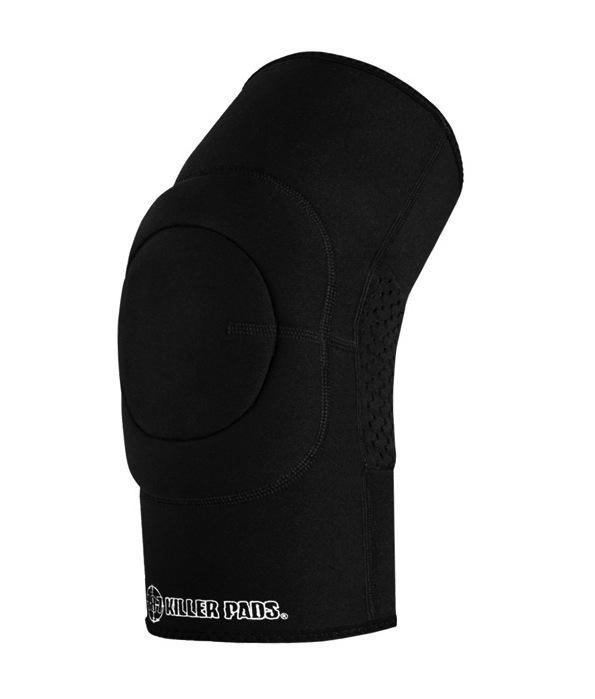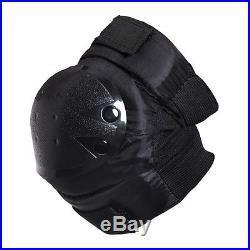The first image is the image on the left, the second image is the image on the right. Examine the images to the left and right. Is the description "There are 3 knee braces in the images." accurate? Answer yes or no. No. The first image is the image on the left, the second image is the image on the right. Assess this claim about the two images: "There are three knee pads.". Correct or not? Answer yes or no. No. 